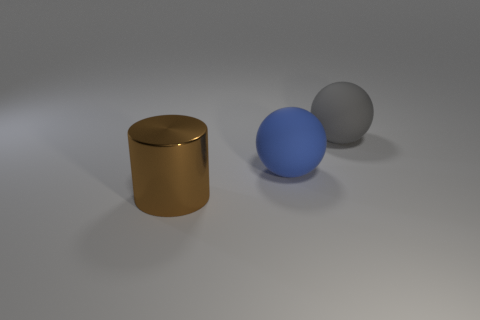Are there any other things that have the same material as the large blue object?
Provide a short and direct response. Yes. Are there any other things that are the same color as the large cylinder?
Make the answer very short. No. There is a cylinder that is the same size as the gray rubber object; what is it made of?
Provide a succinct answer. Metal. What is the color of the shiny thing that is the same size as the blue matte sphere?
Give a very brief answer. Brown. What shape is the big object that is on the left side of the blue matte ball in front of the gray thing?
Make the answer very short. Cylinder. The big object that is both in front of the gray sphere and behind the big shiny thing is what color?
Offer a terse response. Blue. Are there any big blue things made of the same material as the gray object?
Your answer should be compact. Yes. There is a blue thing that is the same shape as the gray thing; what is it made of?
Your answer should be very brief. Rubber. What number of big cyan cylinders are there?
Your answer should be very brief. 0. There is a large cylinder that is on the left side of the large ball to the left of the rubber object behind the large blue sphere; what color is it?
Make the answer very short. Brown. 